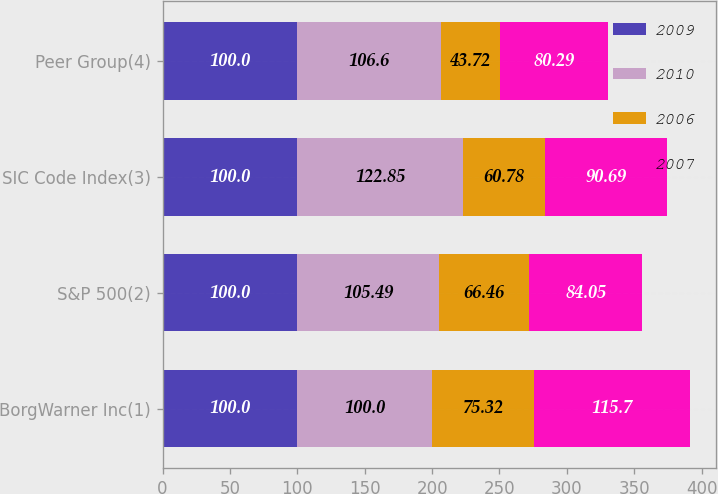Convert chart to OTSL. <chart><loc_0><loc_0><loc_500><loc_500><stacked_bar_chart><ecel><fcel>BorgWarner Inc(1)<fcel>S&P 500(2)<fcel>SIC Code Index(3)<fcel>Peer Group(4)<nl><fcel>2009<fcel>100<fcel>100<fcel>100<fcel>100<nl><fcel>2010<fcel>100<fcel>105.49<fcel>122.85<fcel>106.6<nl><fcel>2006<fcel>75.32<fcel>66.46<fcel>60.78<fcel>43.72<nl><fcel>2007<fcel>115.7<fcel>84.05<fcel>90.69<fcel>80.29<nl></chart> 